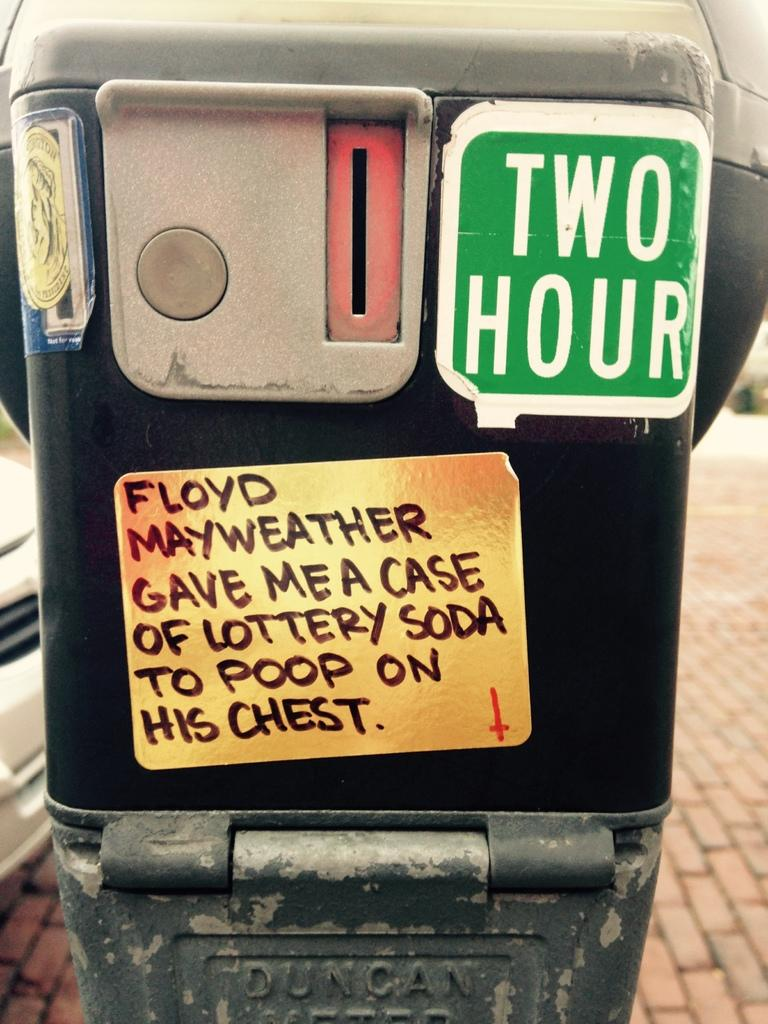<image>
Present a compact description of the photo's key features. Parking meter wit ha sticker that says TWO HOUR. 